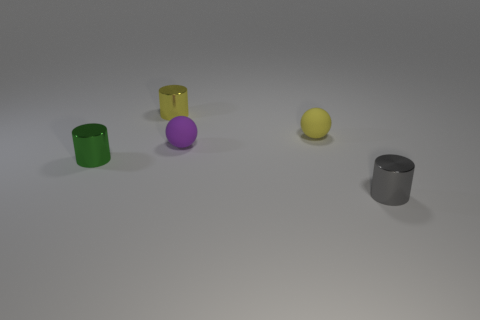Add 2 tiny metal things. How many objects exist? 7 Subtract all balls. How many objects are left? 3 Add 2 spheres. How many spheres are left? 4 Add 3 tiny green metallic objects. How many tiny green metallic objects exist? 4 Subtract 0 purple cylinders. How many objects are left? 5 Subtract all small metal things. Subtract all spheres. How many objects are left? 0 